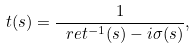<formula> <loc_0><loc_0><loc_500><loc_500>t ( s ) = \frac { 1 } { \ r e t ^ { - 1 } ( s ) - i \sigma ( s ) } ,</formula> 